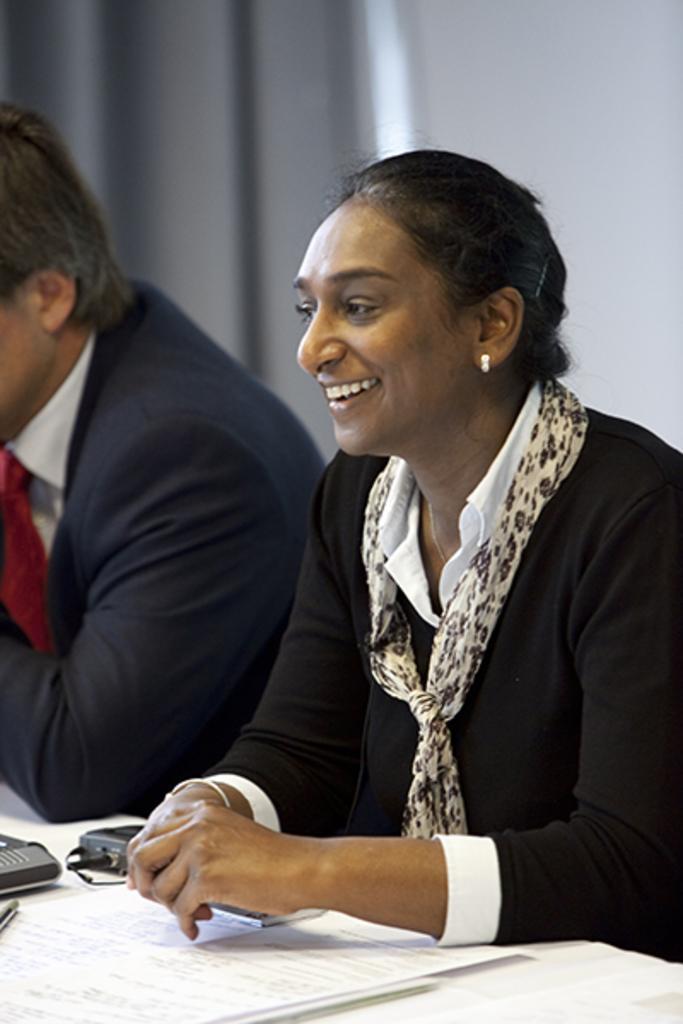Can you describe this image briefly? In this image I can see two people sitting and wearing different color dresses. I can see few papers and some objects. Back I can see a grey and white background. 